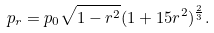Convert formula to latex. <formula><loc_0><loc_0><loc_500><loc_500>p _ { r } = p _ { 0 } \sqrt { 1 - r ^ { 2 } } ( 1 + 1 5 r ^ { 2 } ) ^ { \frac { 2 } { 3 } } .</formula> 